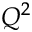<formula> <loc_0><loc_0><loc_500><loc_500>Q ^ { 2 }</formula> 